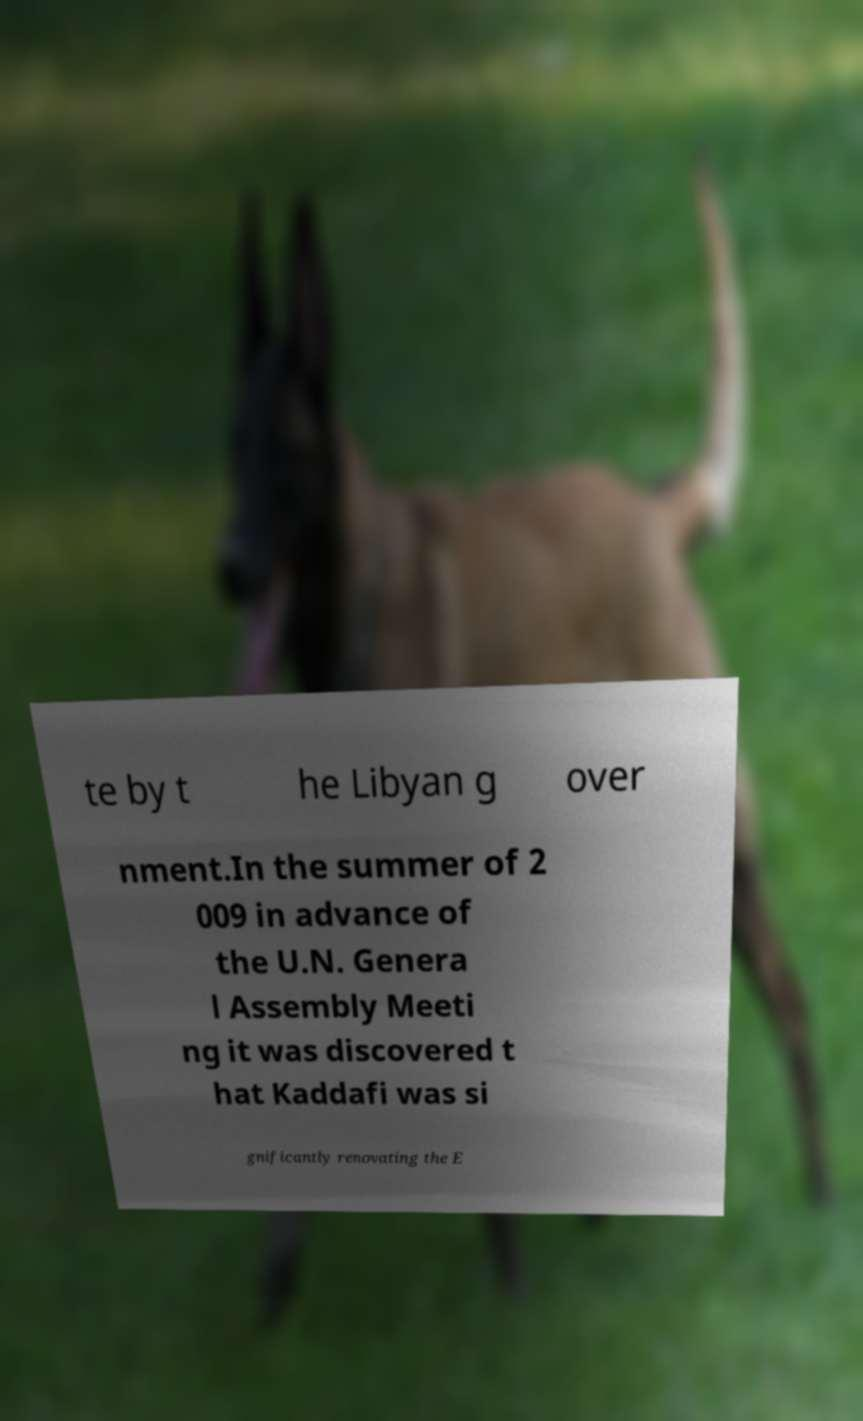Please read and relay the text visible in this image. What does it say? te by t he Libyan g over nment.In the summer of 2 009 in advance of the U.N. Genera l Assembly Meeti ng it was discovered t hat Kaddafi was si gnificantly renovating the E 